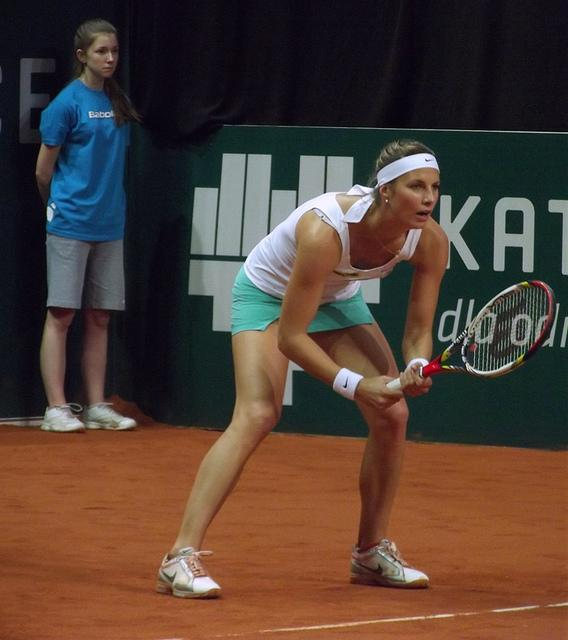What is she ready to do? hit ball 